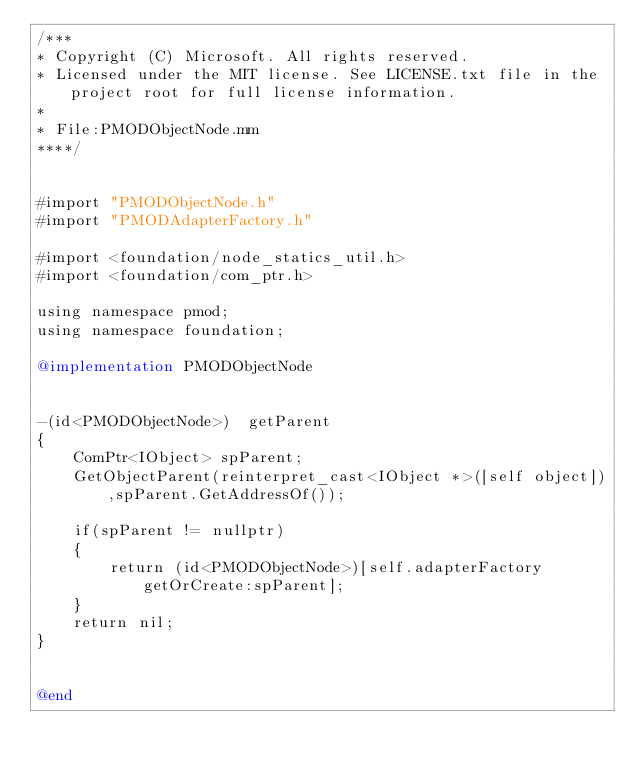Convert code to text. <code><loc_0><loc_0><loc_500><loc_500><_ObjectiveC_>/***
* Copyright (C) Microsoft. All rights reserved.
* Licensed under the MIT license. See LICENSE.txt file in the project root for full license information.
*
* File:PMODObjectNode.mm
****/


#import "PMODObjectNode.h"
#import "PMODAdapterFactory.h"

#import <foundation/node_statics_util.h>
#import <foundation/com_ptr.h>

using namespace pmod;
using namespace foundation;

@implementation PMODObjectNode


-(id<PMODObjectNode>)  getParent
{
    ComPtr<IObject> spParent;
    GetObjectParent(reinterpret_cast<IObject *>([self object]),spParent.GetAddressOf());
    
    if(spParent != nullptr)
    {
        return (id<PMODObjectNode>)[self.adapterFactory getOrCreate:spParent];
    }
    return nil;
}


@end
</code> 